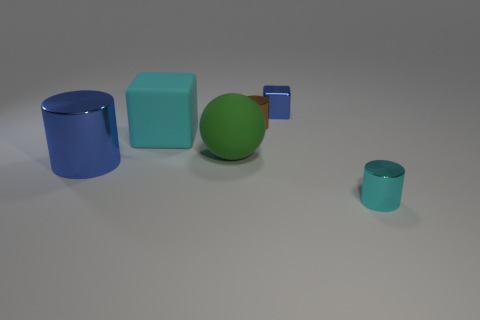Add 1 big shiny objects. How many objects exist? 7 Subtract all balls. How many objects are left? 5 Add 3 large blue metal objects. How many large blue metal objects are left? 4 Add 2 matte blocks. How many matte blocks exist? 3 Subtract 0 red cylinders. How many objects are left? 6 Subtract all small cubes. Subtract all cyan cubes. How many objects are left? 4 